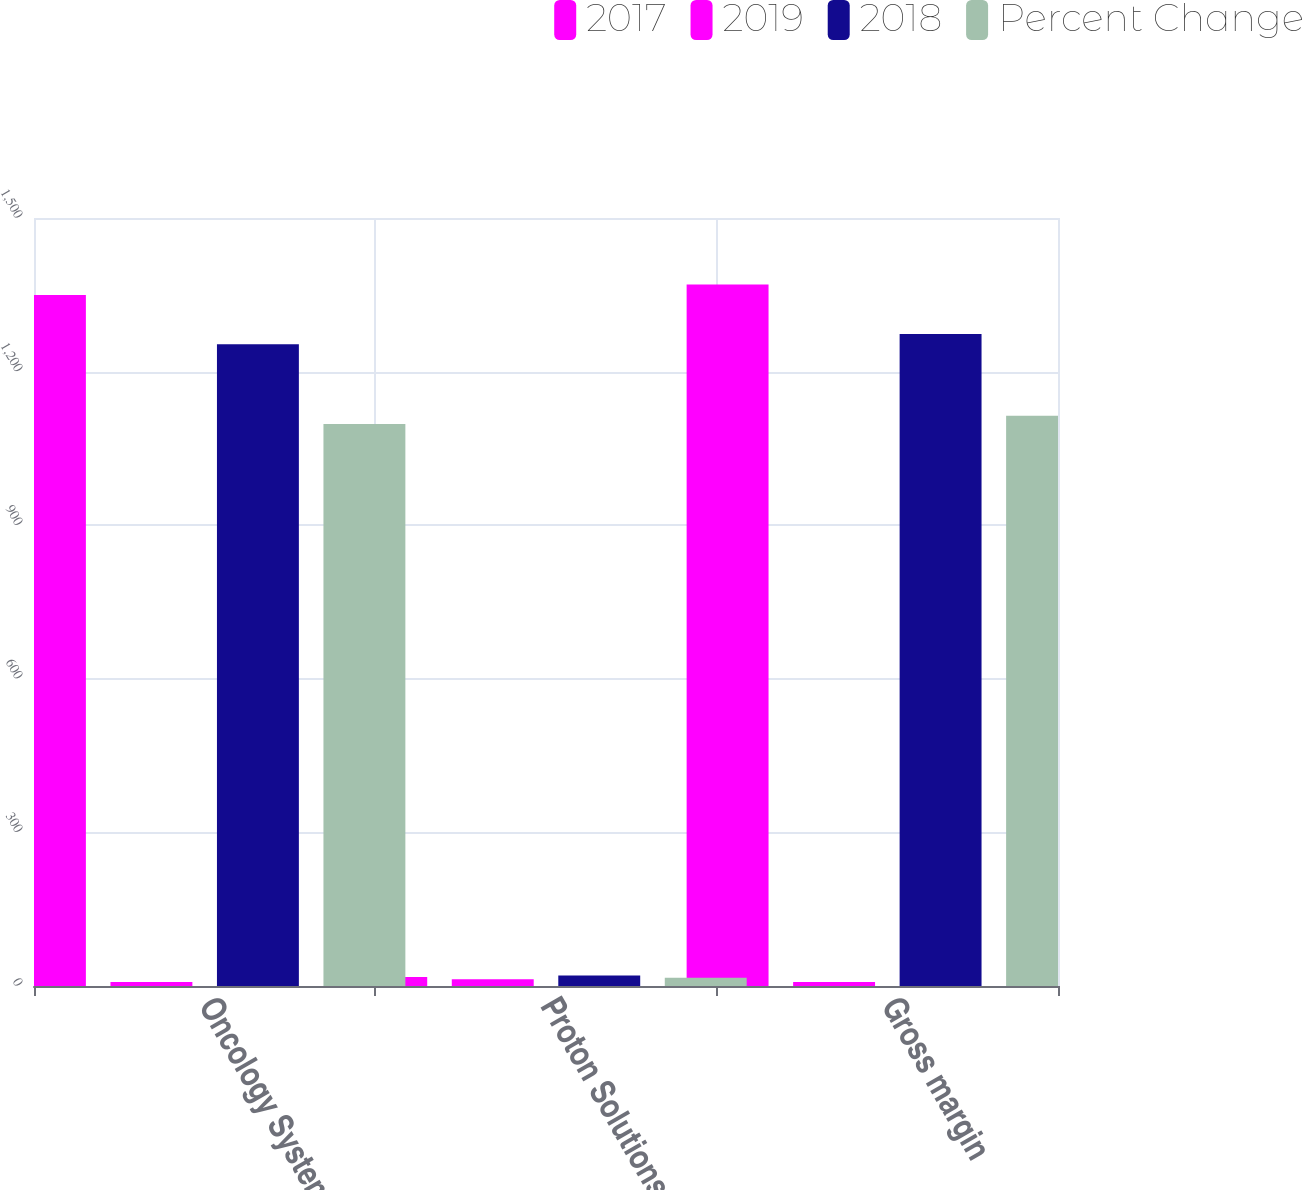Convert chart to OTSL. <chart><loc_0><loc_0><loc_500><loc_500><stacked_bar_chart><ecel><fcel>Oncology Systems<fcel>Proton Solutions<fcel>Gross margin<nl><fcel>2017<fcel>1349.4<fcel>17.7<fcel>1370.3<nl><fcel>2019<fcel>8<fcel>13<fcel>8<nl><fcel>2018<fcel>1253.2<fcel>20.4<fcel>1273.6<nl><fcel>Percent Change<fcel>1097.9<fcel>16<fcel>1113.9<nl></chart> 